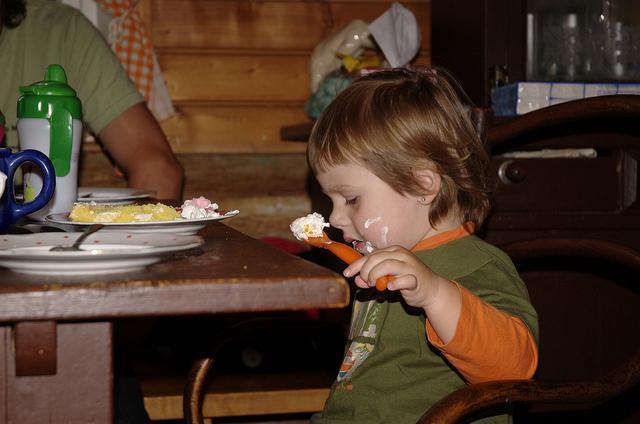How many hotdogs are on the plates?
Give a very brief answer. 0. How many people are in the picture?
Give a very brief answer. 2. 